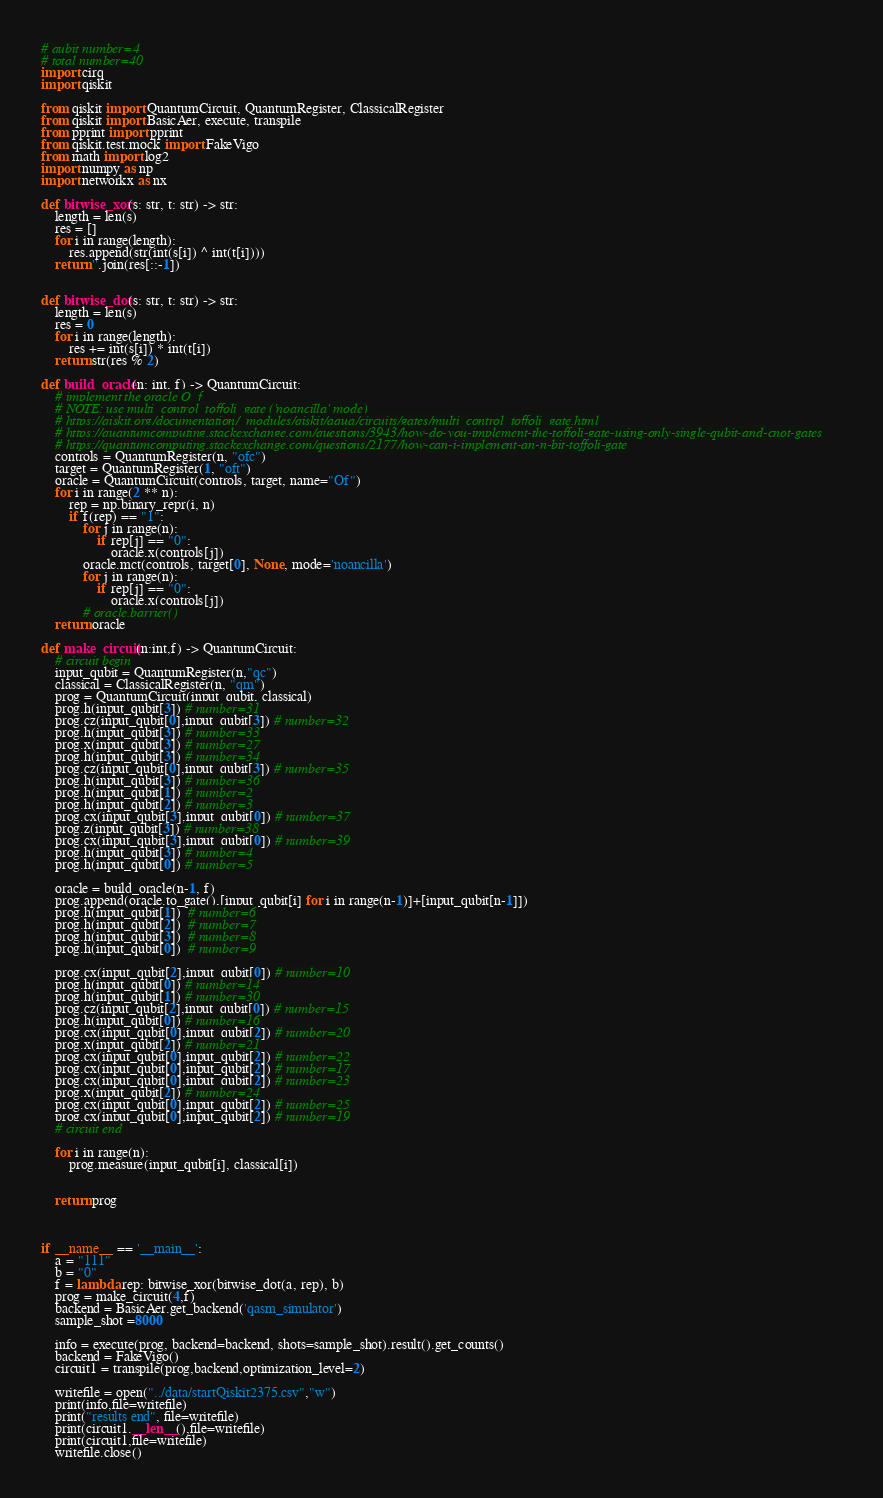Convert code to text. <code><loc_0><loc_0><loc_500><loc_500><_Python_># qubit number=4
# total number=40
import cirq
import qiskit

from qiskit import QuantumCircuit, QuantumRegister, ClassicalRegister
from qiskit import BasicAer, execute, transpile
from pprint import pprint
from qiskit.test.mock import FakeVigo
from math import log2
import numpy as np
import networkx as nx

def bitwise_xor(s: str, t: str) -> str:
    length = len(s)
    res = []
    for i in range(length):
        res.append(str(int(s[i]) ^ int(t[i])))
    return ''.join(res[::-1])


def bitwise_dot(s: str, t: str) -> str:
    length = len(s)
    res = 0
    for i in range(length):
        res += int(s[i]) * int(t[i])
    return str(res % 2)

def build_oracle(n: int, f) -> QuantumCircuit:
    # implement the oracle O_f
    # NOTE: use multi_control_toffoli_gate ('noancilla' mode)
    # https://qiskit.org/documentation/_modules/qiskit/aqua/circuits/gates/multi_control_toffoli_gate.html
    # https://quantumcomputing.stackexchange.com/questions/3943/how-do-you-implement-the-toffoli-gate-using-only-single-qubit-and-cnot-gates
    # https://quantumcomputing.stackexchange.com/questions/2177/how-can-i-implement-an-n-bit-toffoli-gate
    controls = QuantumRegister(n, "ofc")
    target = QuantumRegister(1, "oft")
    oracle = QuantumCircuit(controls, target, name="Of")
    for i in range(2 ** n):
        rep = np.binary_repr(i, n)
        if f(rep) == "1":
            for j in range(n):
                if rep[j] == "0":
                    oracle.x(controls[j])
            oracle.mct(controls, target[0], None, mode='noancilla')
            for j in range(n):
                if rep[j] == "0":
                    oracle.x(controls[j])
            # oracle.barrier()
    return oracle

def make_circuit(n:int,f) -> QuantumCircuit:
    # circuit begin
    input_qubit = QuantumRegister(n,"qc")
    classical = ClassicalRegister(n, "qm")
    prog = QuantumCircuit(input_qubit, classical)
    prog.h(input_qubit[3]) # number=31
    prog.cz(input_qubit[0],input_qubit[3]) # number=32
    prog.h(input_qubit[3]) # number=33
    prog.x(input_qubit[3]) # number=27
    prog.h(input_qubit[3]) # number=34
    prog.cz(input_qubit[0],input_qubit[3]) # number=35
    prog.h(input_qubit[3]) # number=36
    prog.h(input_qubit[1]) # number=2
    prog.h(input_qubit[2]) # number=3
    prog.cx(input_qubit[3],input_qubit[0]) # number=37
    prog.z(input_qubit[3]) # number=38
    prog.cx(input_qubit[3],input_qubit[0]) # number=39
    prog.h(input_qubit[3]) # number=4
    prog.h(input_qubit[0]) # number=5

    oracle = build_oracle(n-1, f)
    prog.append(oracle.to_gate(),[input_qubit[i] for i in range(n-1)]+[input_qubit[n-1]])
    prog.h(input_qubit[1])  # number=6
    prog.h(input_qubit[2])  # number=7
    prog.h(input_qubit[3])  # number=8
    prog.h(input_qubit[0])  # number=9

    prog.cx(input_qubit[2],input_qubit[0]) # number=10
    prog.h(input_qubit[0]) # number=14
    prog.h(input_qubit[1]) # number=30
    prog.cz(input_qubit[2],input_qubit[0]) # number=15
    prog.h(input_qubit[0]) # number=16
    prog.cx(input_qubit[0],input_qubit[2]) # number=20
    prog.x(input_qubit[2]) # number=21
    prog.cx(input_qubit[0],input_qubit[2]) # number=22
    prog.cx(input_qubit[0],input_qubit[2]) # number=17
    prog.cx(input_qubit[0],input_qubit[2]) # number=23
    prog.x(input_qubit[2]) # number=24
    prog.cx(input_qubit[0],input_qubit[2]) # number=25
    prog.cx(input_qubit[0],input_qubit[2]) # number=19
    # circuit end

    for i in range(n):
        prog.measure(input_qubit[i], classical[i])


    return prog



if __name__ == '__main__':
    a = "111"
    b = "0"
    f = lambda rep: bitwise_xor(bitwise_dot(a, rep), b)
    prog = make_circuit(4,f)
    backend = BasicAer.get_backend('qasm_simulator')
    sample_shot =8000

    info = execute(prog, backend=backend, shots=sample_shot).result().get_counts()
    backend = FakeVigo()
    circuit1 = transpile(prog,backend,optimization_level=2)

    writefile = open("../data/startQiskit2375.csv","w")
    print(info,file=writefile)
    print("results end", file=writefile)
    print(circuit1.__len__(),file=writefile)
    print(circuit1,file=writefile)
    writefile.close()
</code> 